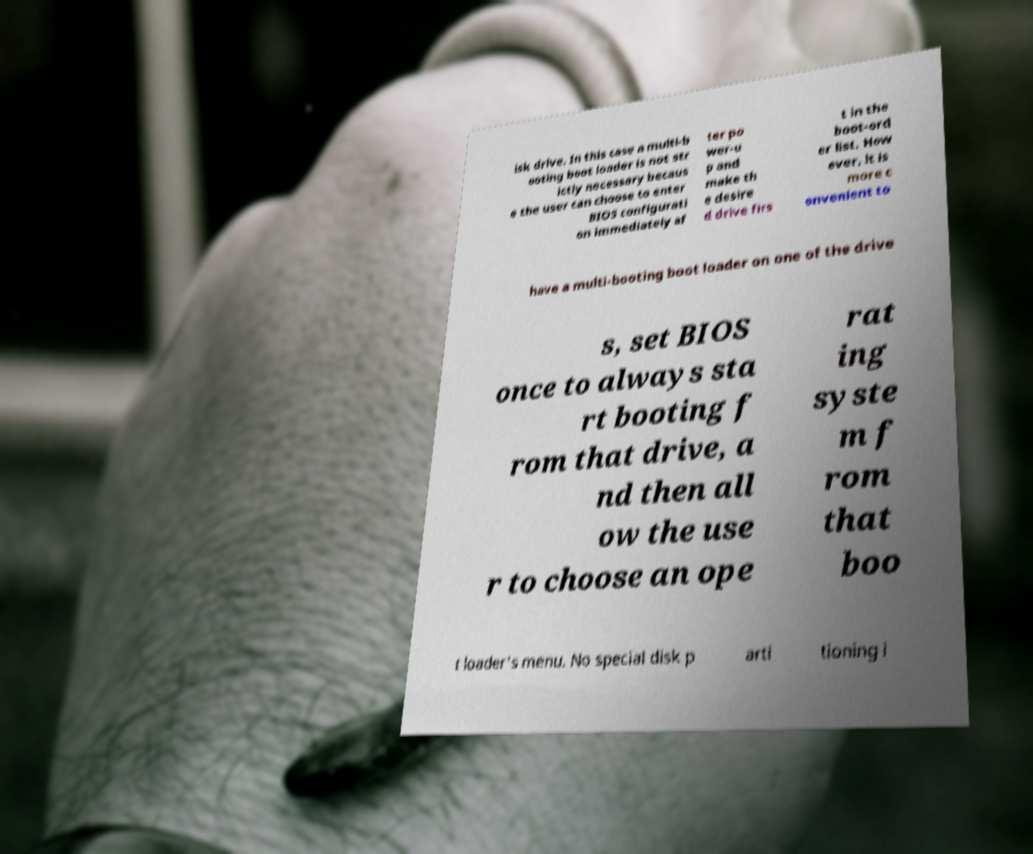For documentation purposes, I need the text within this image transcribed. Could you provide that? isk drive. In this case a multi-b ooting boot loader is not str ictly necessary becaus e the user can choose to enter BIOS configurati on immediately af ter po wer-u p and make th e desire d drive firs t in the boot-ord er list. How ever, it is more c onvenient to have a multi-booting boot loader on one of the drive s, set BIOS once to always sta rt booting f rom that drive, a nd then all ow the use r to choose an ope rat ing syste m f rom that boo t loader's menu. No special disk p arti tioning i 